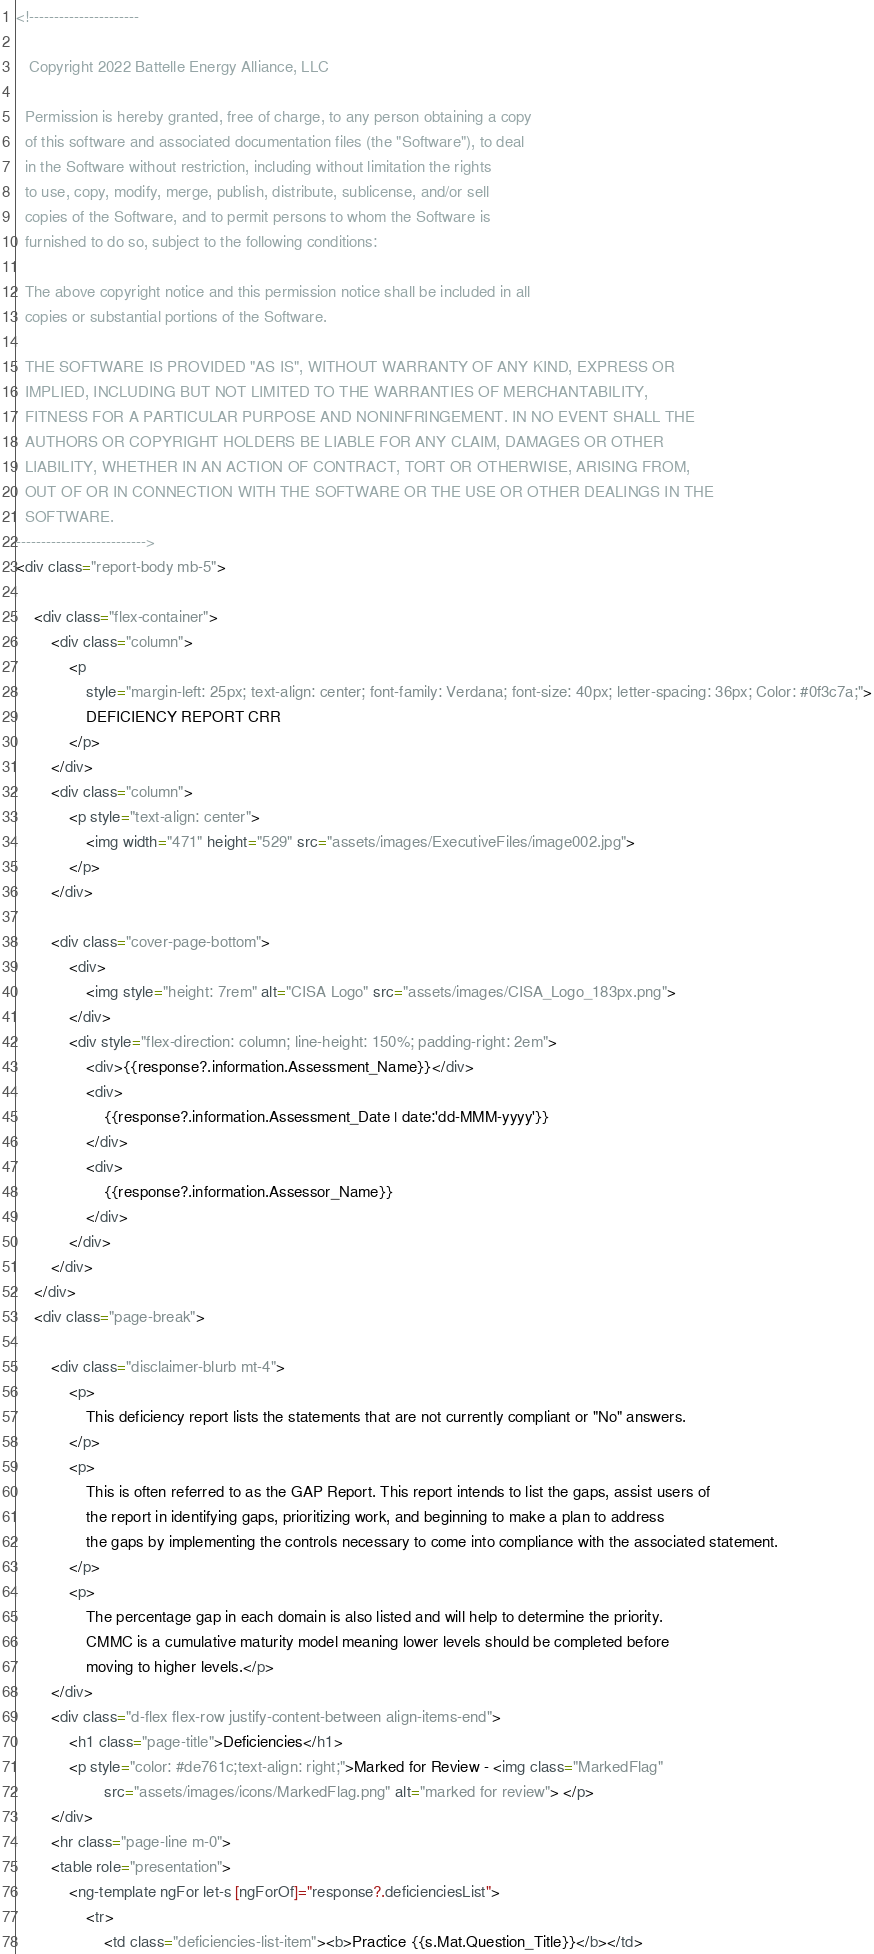Convert code to text. <code><loc_0><loc_0><loc_500><loc_500><_HTML_><!---------------------- 

   Copyright 2022 Battelle Energy Alliance, LLC  

  Permission is hereby granted, free of charge, to any person obtaining a copy 
  of this software and associated documentation files (the "Software"), to deal 
  in the Software without restriction, including without limitation the rights 
  to use, copy, modify, merge, publish, distribute, sublicense, and/or sell 
  copies of the Software, and to permit persons to whom the Software is 
  furnished to do so, subject to the following conditions: 
 
  The above copyright notice and this permission notice shall be included in all 
  copies or substantial portions of the Software. 
 
  THE SOFTWARE IS PROVIDED "AS IS", WITHOUT WARRANTY OF ANY KIND, EXPRESS OR 
  IMPLIED, INCLUDING BUT NOT LIMITED TO THE WARRANTIES OF MERCHANTABILITY, 
  FITNESS FOR A PARTICULAR PURPOSE AND NONINFRINGEMENT. IN NO EVENT SHALL THE 
  AUTHORS OR COPYRIGHT HOLDERS BE LIABLE FOR ANY CLAIM, DAMAGES OR OTHER 
  LIABILITY, WHETHER IN AN ACTION OF CONTRACT, TORT OR OTHERWISE, ARISING FROM, 
  OUT OF OR IN CONNECTION WITH THE SOFTWARE OR THE USE OR OTHER DEALINGS IN THE 
  SOFTWARE. 
-------------------------->
<div class="report-body mb-5">

    <div class="flex-container">
        <div class="column">
            <p
                style="margin-left: 25px; text-align: center; font-family: Verdana; font-size: 40px; letter-spacing: 36px; Color: #0f3c7a;">
                DEFICIENCY REPORT CRR
            </p>
        </div>
        <div class="column">
            <p style="text-align: center">
                <img width="471" height="529" src="assets/images/ExecutiveFiles/image002.jpg">
            </p>
        </div>

        <div class="cover-page-bottom">
            <div>
                <img style="height: 7rem" alt="CISA Logo" src="assets/images/CISA_Logo_183px.png">
            </div>
            <div style="flex-direction: column; line-height: 150%; padding-right: 2em">
                <div>{{response?.information.Assessment_Name}}</div>
                <div>
                    {{response?.information.Assessment_Date | date:'dd-MMM-yyyy'}}
                </div>
                <div>
                    {{response?.information.Assessor_Name}}
                </div>
            </div>
        </div>
    </div>
    <div class="page-break">

        <div class="disclaimer-blurb mt-4">
            <p>
                This deficiency report lists the statements that are not currently compliant or "No" answers.
            </p>
            <p>
                This is often referred to as the GAP Report. This report intends to list the gaps, assist users of
                the report in identifying gaps, prioritizing work, and beginning to make a plan to address
                the gaps by implementing the controls necessary to come into compliance with the associated statement.
            </p>
            <p>
                The percentage gap in each domain is also listed and will help to determine the priority.
                CMMC is a cumulative maturity model meaning lower levels should be completed before
                moving to higher levels.</p>
        </div>
        <div class="d-flex flex-row justify-content-between align-items-end">
            <h1 class="page-title">Deficiencies</h1>
            <p style="color: #de761c;text-align: right;">Marked for Review - <img class="MarkedFlag"
                    src="assets/images/icons/MarkedFlag.png" alt="marked for review"> </p>
        </div>
        <hr class="page-line m-0">
        <table role="presentation">
            <ng-template ngFor let-s [ngForOf]="response?.deficienciesList">
                <tr>
                    <td class="deficiencies-list-item"><b>Practice {{s.Mat.Question_Title}}</b></td></code> 